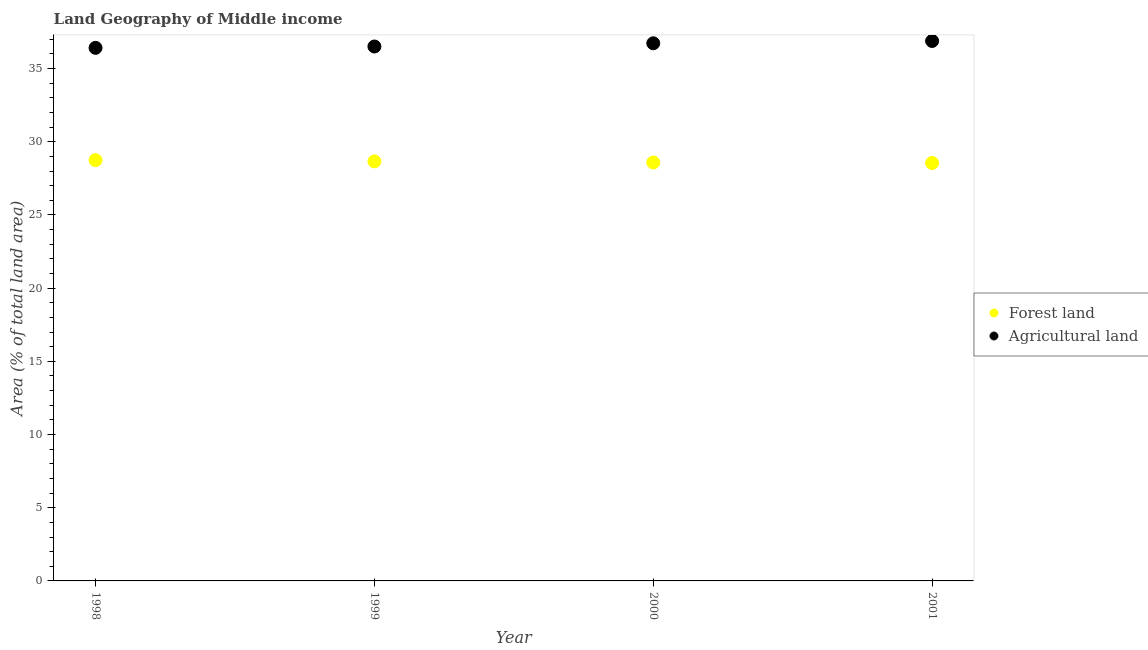How many different coloured dotlines are there?
Your answer should be compact. 2. What is the percentage of land area under agriculture in 2000?
Offer a very short reply. 36.73. Across all years, what is the maximum percentage of land area under agriculture?
Give a very brief answer. 36.88. Across all years, what is the minimum percentage of land area under forests?
Ensure brevity in your answer.  28.55. In which year was the percentage of land area under agriculture minimum?
Your response must be concise. 1998. What is the total percentage of land area under forests in the graph?
Make the answer very short. 114.54. What is the difference between the percentage of land area under forests in 2000 and that in 2001?
Your answer should be very brief. 0.03. What is the difference between the percentage of land area under agriculture in 1998 and the percentage of land area under forests in 2000?
Provide a succinct answer. 7.83. What is the average percentage of land area under agriculture per year?
Offer a terse response. 36.63. In the year 2000, what is the difference between the percentage of land area under forests and percentage of land area under agriculture?
Keep it short and to the point. -8.14. In how many years, is the percentage of land area under agriculture greater than 7 %?
Ensure brevity in your answer.  4. What is the ratio of the percentage of land area under forests in 1999 to that in 2000?
Offer a terse response. 1. What is the difference between the highest and the second highest percentage of land area under agriculture?
Your answer should be very brief. 0.16. What is the difference between the highest and the lowest percentage of land area under agriculture?
Keep it short and to the point. 0.47. In how many years, is the percentage of land area under forests greater than the average percentage of land area under forests taken over all years?
Offer a terse response. 2. Is the sum of the percentage of land area under forests in 2000 and 2001 greater than the maximum percentage of land area under agriculture across all years?
Give a very brief answer. Yes. Is the percentage of land area under forests strictly greater than the percentage of land area under agriculture over the years?
Provide a succinct answer. No. Are the values on the major ticks of Y-axis written in scientific E-notation?
Your answer should be very brief. No. How many legend labels are there?
Provide a succinct answer. 2. What is the title of the graph?
Your answer should be very brief. Land Geography of Middle income. Does "Birth rate" appear as one of the legend labels in the graph?
Keep it short and to the point. No. What is the label or title of the Y-axis?
Offer a very short reply. Area (% of total land area). What is the Area (% of total land area) of Forest land in 1998?
Keep it short and to the point. 28.74. What is the Area (% of total land area) in Agricultural land in 1998?
Provide a succinct answer. 36.41. What is the Area (% of total land area) of Forest land in 1999?
Give a very brief answer. 28.66. What is the Area (% of total land area) of Agricultural land in 1999?
Offer a terse response. 36.51. What is the Area (% of total land area) of Forest land in 2000?
Give a very brief answer. 28.58. What is the Area (% of total land area) of Agricultural land in 2000?
Provide a succinct answer. 36.73. What is the Area (% of total land area) in Forest land in 2001?
Your answer should be very brief. 28.55. What is the Area (% of total land area) in Agricultural land in 2001?
Provide a succinct answer. 36.88. Across all years, what is the maximum Area (% of total land area) in Forest land?
Provide a short and direct response. 28.74. Across all years, what is the maximum Area (% of total land area) of Agricultural land?
Keep it short and to the point. 36.88. Across all years, what is the minimum Area (% of total land area) of Forest land?
Your answer should be very brief. 28.55. Across all years, what is the minimum Area (% of total land area) in Agricultural land?
Keep it short and to the point. 36.41. What is the total Area (% of total land area) of Forest land in the graph?
Make the answer very short. 114.54. What is the total Area (% of total land area) of Agricultural land in the graph?
Offer a very short reply. 146.53. What is the difference between the Area (% of total land area) in Forest land in 1998 and that in 1999?
Give a very brief answer. 0.08. What is the difference between the Area (% of total land area) of Agricultural land in 1998 and that in 1999?
Your answer should be very brief. -0.09. What is the difference between the Area (% of total land area) in Forest land in 1998 and that in 2000?
Make the answer very short. 0.16. What is the difference between the Area (% of total land area) of Agricultural land in 1998 and that in 2000?
Your response must be concise. -0.31. What is the difference between the Area (% of total land area) in Forest land in 1998 and that in 2001?
Give a very brief answer. 0.19. What is the difference between the Area (% of total land area) in Agricultural land in 1998 and that in 2001?
Your answer should be very brief. -0.47. What is the difference between the Area (% of total land area) of Forest land in 1999 and that in 2000?
Provide a succinct answer. 0.08. What is the difference between the Area (% of total land area) of Agricultural land in 1999 and that in 2000?
Provide a short and direct response. -0.22. What is the difference between the Area (% of total land area) of Forest land in 1999 and that in 2001?
Provide a succinct answer. 0.11. What is the difference between the Area (% of total land area) in Agricultural land in 1999 and that in 2001?
Give a very brief answer. -0.38. What is the difference between the Area (% of total land area) of Forest land in 2000 and that in 2001?
Ensure brevity in your answer.  0.03. What is the difference between the Area (% of total land area) in Agricultural land in 2000 and that in 2001?
Keep it short and to the point. -0.16. What is the difference between the Area (% of total land area) in Forest land in 1998 and the Area (% of total land area) in Agricultural land in 1999?
Keep it short and to the point. -7.76. What is the difference between the Area (% of total land area) in Forest land in 1998 and the Area (% of total land area) in Agricultural land in 2000?
Make the answer very short. -7.98. What is the difference between the Area (% of total land area) in Forest land in 1998 and the Area (% of total land area) in Agricultural land in 2001?
Offer a terse response. -8.14. What is the difference between the Area (% of total land area) in Forest land in 1999 and the Area (% of total land area) in Agricultural land in 2000?
Ensure brevity in your answer.  -8.07. What is the difference between the Area (% of total land area) in Forest land in 1999 and the Area (% of total land area) in Agricultural land in 2001?
Make the answer very short. -8.22. What is the difference between the Area (% of total land area) in Forest land in 2000 and the Area (% of total land area) in Agricultural land in 2001?
Make the answer very short. -8.3. What is the average Area (% of total land area) in Forest land per year?
Ensure brevity in your answer.  28.63. What is the average Area (% of total land area) of Agricultural land per year?
Ensure brevity in your answer.  36.63. In the year 1998, what is the difference between the Area (% of total land area) in Forest land and Area (% of total land area) in Agricultural land?
Offer a very short reply. -7.67. In the year 1999, what is the difference between the Area (% of total land area) of Forest land and Area (% of total land area) of Agricultural land?
Keep it short and to the point. -7.85. In the year 2000, what is the difference between the Area (% of total land area) in Forest land and Area (% of total land area) in Agricultural land?
Keep it short and to the point. -8.14. In the year 2001, what is the difference between the Area (% of total land area) in Forest land and Area (% of total land area) in Agricultural land?
Ensure brevity in your answer.  -8.33. What is the ratio of the Area (% of total land area) of Forest land in 1998 to that in 1999?
Provide a short and direct response. 1. What is the ratio of the Area (% of total land area) in Forest land in 1998 to that in 2000?
Your answer should be very brief. 1.01. What is the ratio of the Area (% of total land area) in Forest land in 1998 to that in 2001?
Give a very brief answer. 1.01. What is the ratio of the Area (% of total land area) in Agricultural land in 1998 to that in 2001?
Offer a very short reply. 0.99. What is the ratio of the Area (% of total land area) in Agricultural land in 1999 to that in 2000?
Offer a terse response. 0.99. What is the ratio of the Area (% of total land area) of Forest land in 1999 to that in 2001?
Provide a short and direct response. 1. What is the ratio of the Area (% of total land area) in Agricultural land in 1999 to that in 2001?
Provide a succinct answer. 0.99. What is the difference between the highest and the second highest Area (% of total land area) of Forest land?
Provide a short and direct response. 0.08. What is the difference between the highest and the second highest Area (% of total land area) of Agricultural land?
Keep it short and to the point. 0.16. What is the difference between the highest and the lowest Area (% of total land area) in Forest land?
Ensure brevity in your answer.  0.19. What is the difference between the highest and the lowest Area (% of total land area) of Agricultural land?
Your response must be concise. 0.47. 